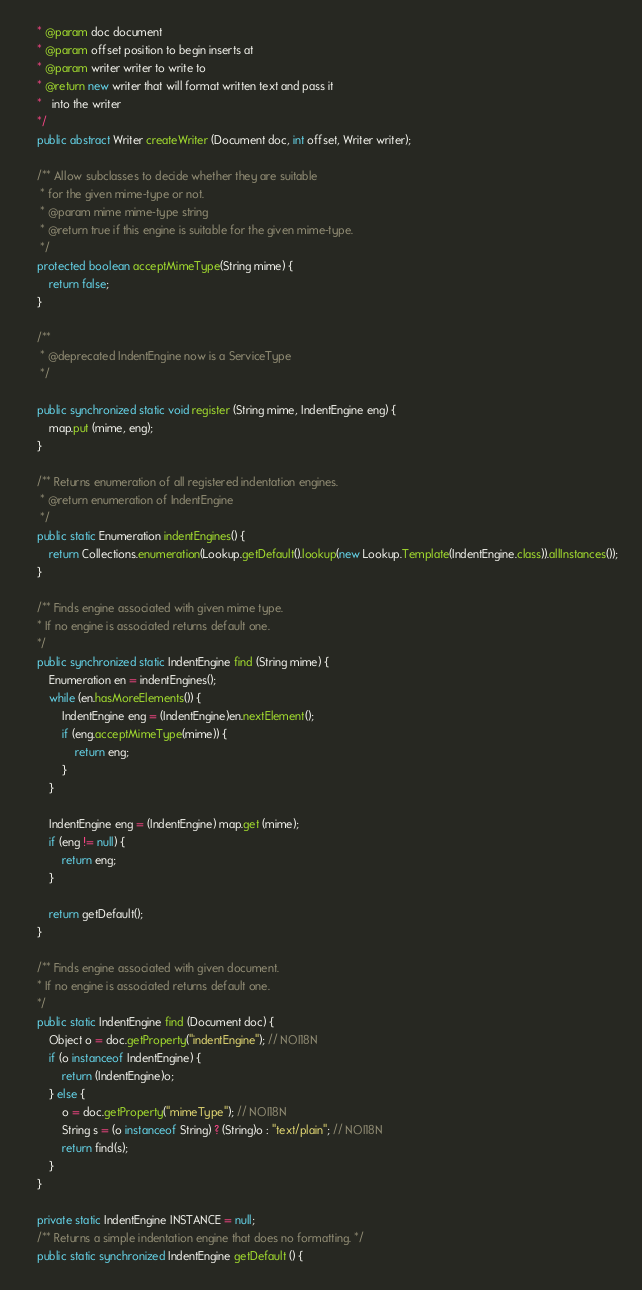<code> <loc_0><loc_0><loc_500><loc_500><_Java_>    * @param doc document 
    * @param offset position to begin inserts at
    * @param writer writer to write to
    * @return new writer that will format written text and pass it
    *   into the writer
    */
    public abstract Writer createWriter (Document doc, int offset, Writer writer);

    /** Allow subclasses to decide whether they are suitable
     * for the given mime-type or not.
     * @param mime mime-type string
     * @return true if this engine is suitable for the given mime-type.
     */
    protected boolean acceptMimeType(String mime) {
        return false;
    }

    /**
     * @deprecated IndentEngine now is a ServiceType
     */
    
    public synchronized static void register (String mime, IndentEngine eng) {
        map.put (mime, eng);
    }
        
    /** Returns enumeration of all registered indentation engines.
     * @return enumeration of IndentEngine
     */
    public static Enumeration indentEngines() {
        return Collections.enumeration(Lookup.getDefault().lookup(new Lookup.Template(IndentEngine.class)).allInstances());
    }

    /** Finds engine associated with given mime type.
    * If no engine is associated returns default one.
    */
    public synchronized static IndentEngine find (String mime) {
        Enumeration en = indentEngines();
        while (en.hasMoreElements()) {
            IndentEngine eng = (IndentEngine)en.nextElement();
            if (eng.acceptMimeType(mime)) {
                return eng;
            }
        }

        IndentEngine eng = (IndentEngine) map.get (mime);
        if (eng != null) {
            return eng;
        }

        return getDefault();
    }

    /** Finds engine associated with given document.
    * If no engine is associated returns default one.
    */
    public static IndentEngine find (Document doc) {
        Object o = doc.getProperty("indentEngine"); // NOI18N
        if (o instanceof IndentEngine) {
            return (IndentEngine)o;
        } else {
            o = doc.getProperty("mimeType"); // NOI18N
            String s = (o instanceof String) ? (String)o : "text/plain"; // NOI18N
            return find(s);
        }
    }

    private static IndentEngine INSTANCE = null;
    /** Returns a simple indentation engine that does no formatting. */
    public static synchronized IndentEngine getDefault () {</code> 